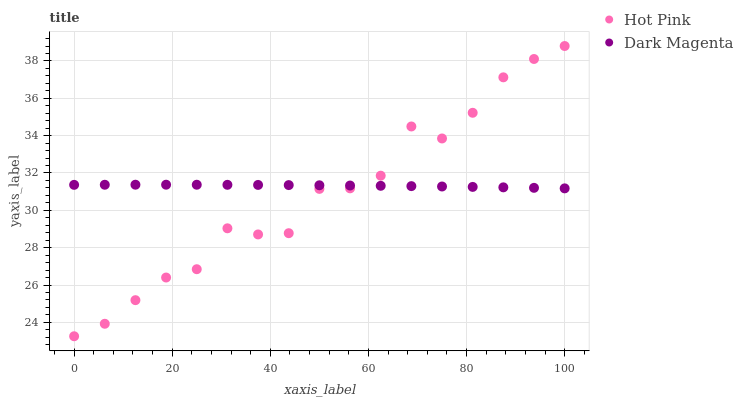Does Hot Pink have the minimum area under the curve?
Answer yes or no. Yes. Does Dark Magenta have the maximum area under the curve?
Answer yes or no. Yes. Does Dark Magenta have the minimum area under the curve?
Answer yes or no. No. Is Dark Magenta the smoothest?
Answer yes or no. Yes. Is Hot Pink the roughest?
Answer yes or no. Yes. Is Dark Magenta the roughest?
Answer yes or no. No. Does Hot Pink have the lowest value?
Answer yes or no. Yes. Does Dark Magenta have the lowest value?
Answer yes or no. No. Does Hot Pink have the highest value?
Answer yes or no. Yes. Does Dark Magenta have the highest value?
Answer yes or no. No. Does Dark Magenta intersect Hot Pink?
Answer yes or no. Yes. Is Dark Magenta less than Hot Pink?
Answer yes or no. No. Is Dark Magenta greater than Hot Pink?
Answer yes or no. No. 